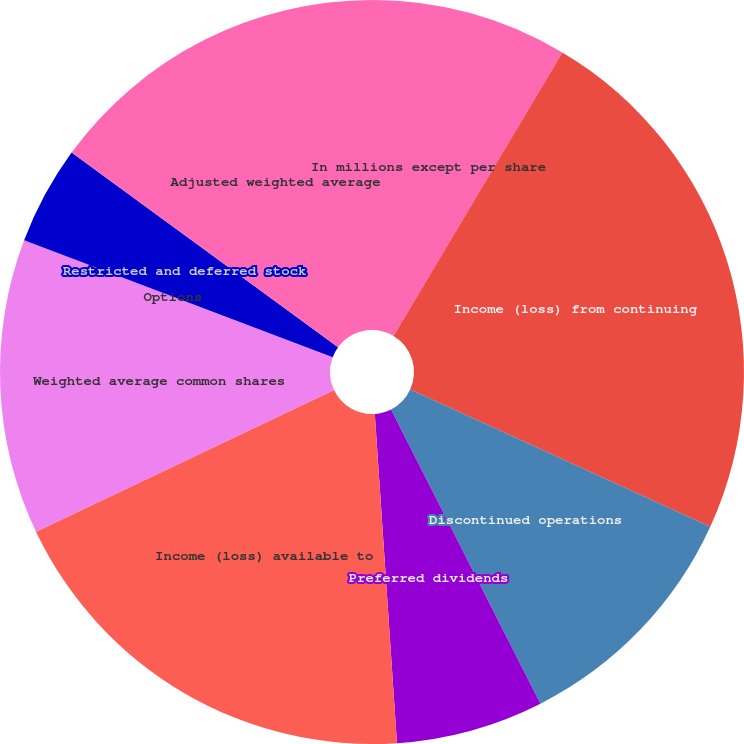Convert chart. <chart><loc_0><loc_0><loc_500><loc_500><pie_chart><fcel>In millions except per share<fcel>Income (loss) from continuing<fcel>Discontinued operations<fcel>Preferred dividends<fcel>Income (loss) available to<fcel>Weighted average common shares<fcel>Options<fcel>Restricted and deferred stock<fcel>Adjusted weighted average<nl><fcel>8.55%<fcel>23.28%<fcel>10.69%<fcel>6.41%<fcel>19.01%<fcel>12.82%<fcel>0.0%<fcel>4.28%<fcel>14.96%<nl></chart> 